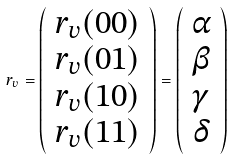Convert formula to latex. <formula><loc_0><loc_0><loc_500><loc_500>r _ { v } = \left ( \begin{array} { c } r _ { v } ( 0 0 ) \\ r _ { v } ( 0 1 ) \\ r _ { v } ( 1 0 ) \\ r _ { v } ( 1 1 ) \end{array} \right ) = \left ( \begin{array} { c } \alpha \\ \beta \\ \gamma \\ \delta \end{array} \right )</formula> 